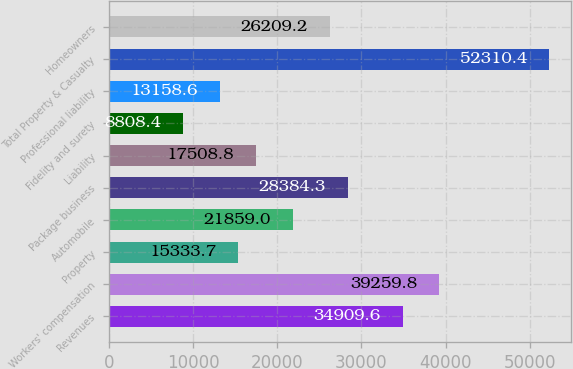Convert chart to OTSL. <chart><loc_0><loc_0><loc_500><loc_500><bar_chart><fcel>Revenues<fcel>Workers' compensation<fcel>Property<fcel>Automobile<fcel>Package business<fcel>Liability<fcel>Fidelity and surety<fcel>Professional liability<fcel>Total Property & Casualty<fcel>Homeowners<nl><fcel>34909.6<fcel>39259.8<fcel>15333.7<fcel>21859<fcel>28384.3<fcel>17508.8<fcel>8808.4<fcel>13158.6<fcel>52310.4<fcel>26209.2<nl></chart> 